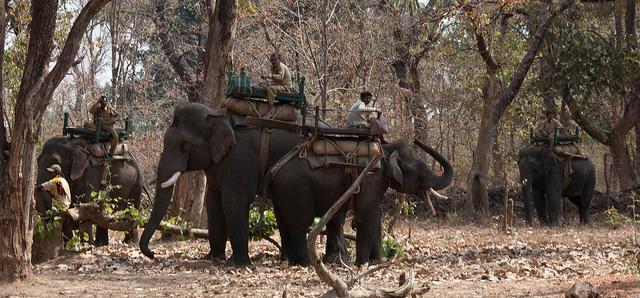How many elephants can you see?
Give a very brief answer. 4. How many elephants are in the photo?
Give a very brief answer. 4. How many black donut are there this images?
Give a very brief answer. 0. 